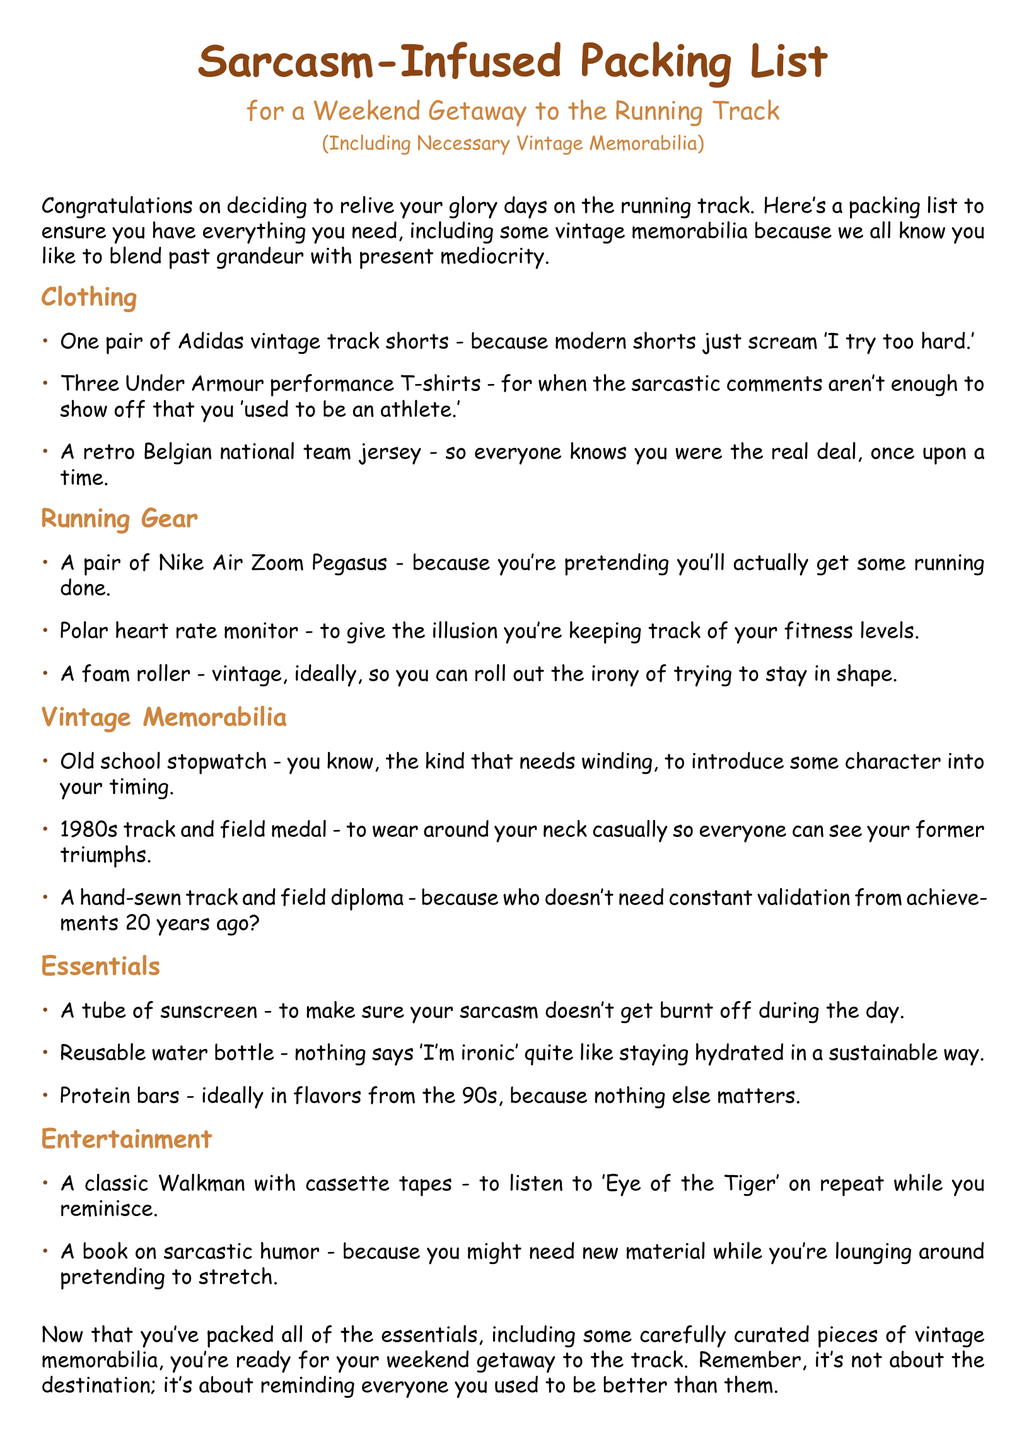what is the main theme of the packing list? The packing list focuses on packing items for a weekend getaway to the running track, infused with sarcasm and vintage memorabilia.
Answer: sarcasm-infused packing list how many Under Armour performance T-shirts are listed? The document specifies three Under Armour performance T-shirts in the clothing section.
Answer: three what type of vintage memorabilia is mentioned? The vintage memorabilia section lists an old school stopwatch.
Answer: old school stopwatch what is suggested as a running shoe? One item in the running gear section is a pair of Nike Air Zoom Pegasus.
Answer: Nike Air Zoom Pegasus which sunscreen characteristic is humorously noted? The document mentions that the sunscreen is for preventing sarcastic comments from getting burnt off.
Answer: sarcastic comments how many categories are in the packing list? The packing list has five distinct categories: Clothing, Running Gear, Vintage Memorabilia, Essentials, and Entertainment.
Answer: five what is recommended for hydration? A reusable water bottle is suggested in the essentials section for hydration.
Answer: reusable water bottle what 1980s item is included for entertainment? A classic Walkman with cassette tapes is listed as an entertainment item in the packing list.
Answer: classic Walkman what type of diploma is humorously referenced? A hand-sewn track and field diploma is mentioned in the vintage memorabilia section.
Answer: hand-sewn track and field diploma 